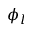Convert formula to latex. <formula><loc_0><loc_0><loc_500><loc_500>\phi _ { l }</formula> 